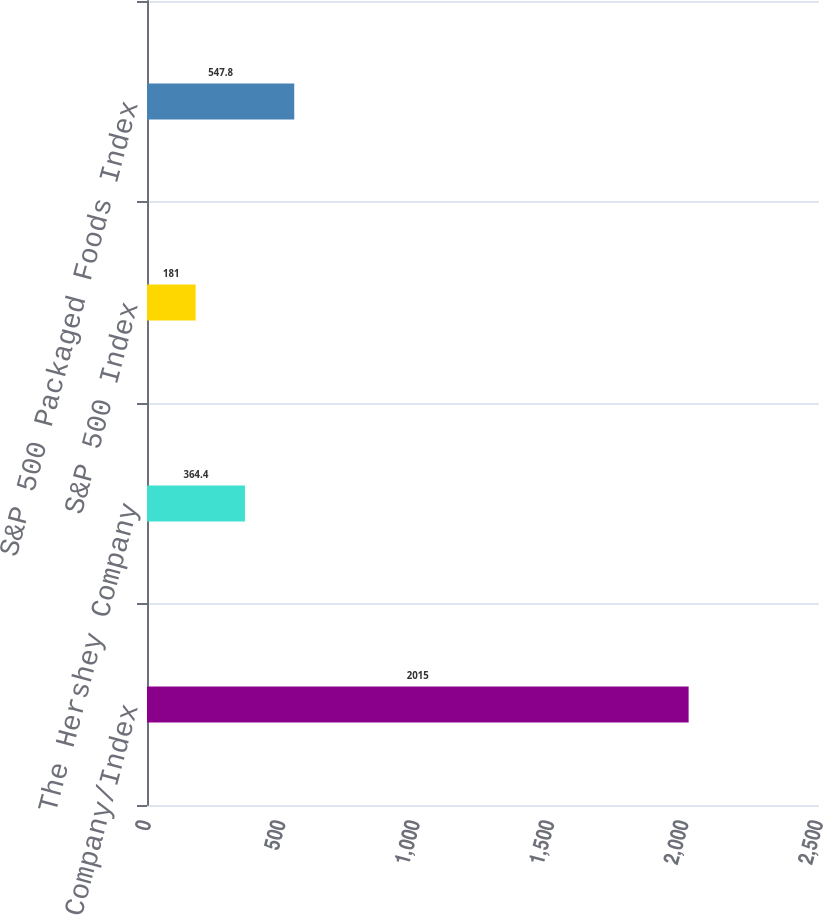Convert chart to OTSL. <chart><loc_0><loc_0><loc_500><loc_500><bar_chart><fcel>Company/Index<fcel>The Hershey Company<fcel>S&P 500 Index<fcel>S&P 500 Packaged Foods Index<nl><fcel>2015<fcel>364.4<fcel>181<fcel>547.8<nl></chart> 